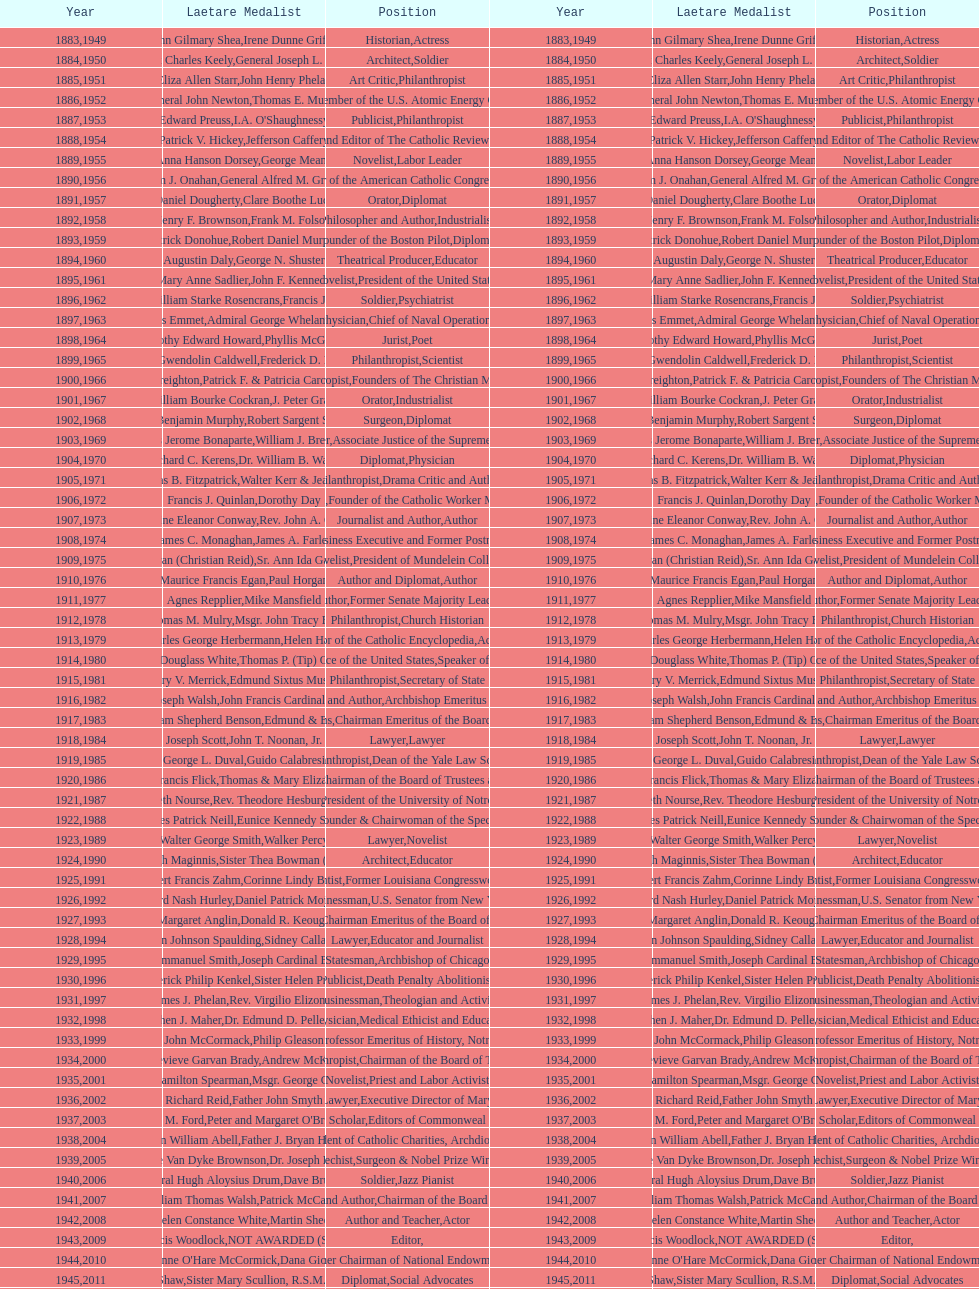Who has won this medal and the nobel prize as well? Dr. Joseph E. Murray. 